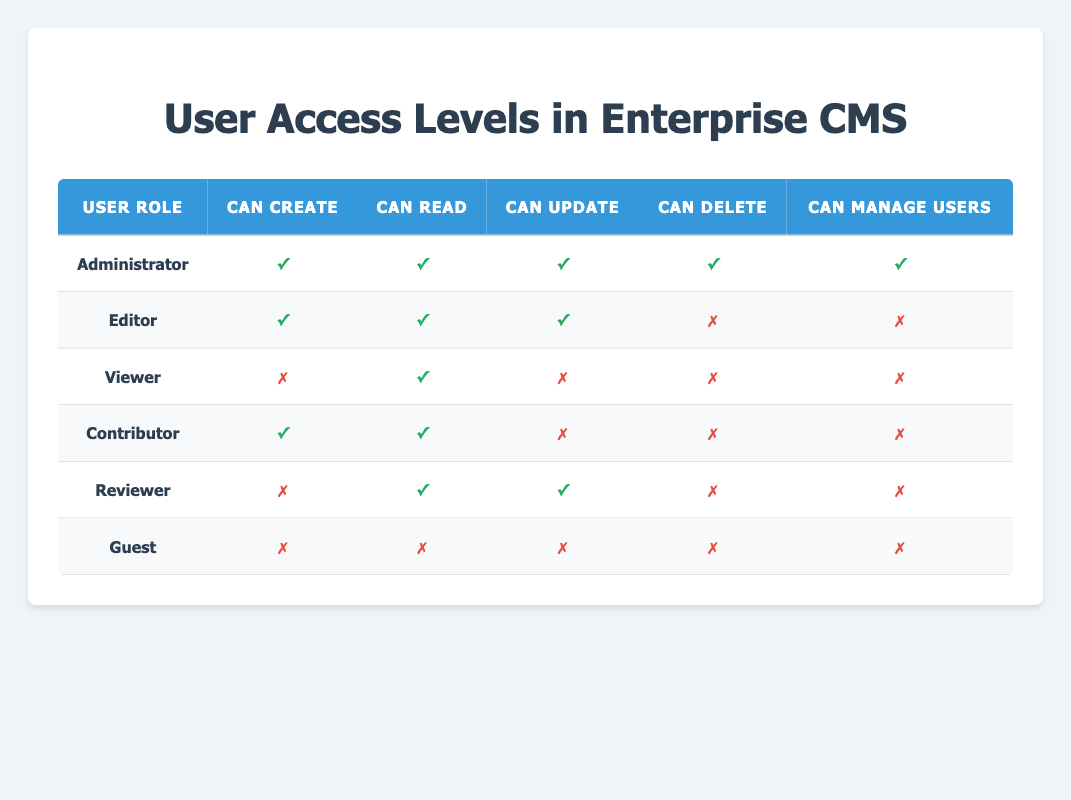What user role has the ability to manage users? By looking at the table, we can see that the "Administrator" role is the only one with "Can Manage Users" marked as true.
Answer: Administrator How many roles have the permission to create content? In the table, there are 4 roles that can create content: Administrator, Editor, Contributor, and Reviewer. We count them to find the total, which is 4.
Answer: 4 Is it true that the Editor can delete content? Referring to the table, we see that for the Editor role, "Can Delete" is marked as false, indicating that the Editor cannot delete content.
Answer: No Which user roles can read content? By checking all roles in the table, we find that the Administrator, Editor, Viewer, Contributor, and Reviewer can read content. Therefore, there are 5 roles with this permission.
Answer: 5 What is the difference in the ability to create content between Administrators and Guests? From the table, we observe that Administrators can create content (true) while Guests cannot (false). The difference is 1 role that can create content.
Answer: 1 Do any user roles exist that can both update and manage users? Looking through the table, we find that only the Administrator has both "Can Update" and "Can Manage Users" marked as true. Therefore, there is only one role meeting both conditions.
Answer: Yes How many user roles cannot delete any content? By examining the table, we see that the Editor, Viewer, Contributor, Reviewer, and Guest roles cannot delete content, totaling 5 roles without delete permissions.
Answer: 5 What percentage of roles can update content? There are 3 roles (Administrator, Editor, and Reviewer) that can update content out of 6 total roles. To calculate the percentage, we do (3/6) * 100 = 50%.
Answer: 50% Which user role has the least permissions? By comparing all permissions in the table, it is clear that the Guest role has all permissions marked as false, making it the role with the least permissions.
Answer: Guest 